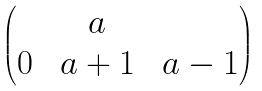Convert formula to latex. <formula><loc_0><loc_0><loc_500><loc_500>\begin{pmatrix} & \ a & \\ 0 & \ a + 1 & \ a - 1 \end{pmatrix}</formula> 